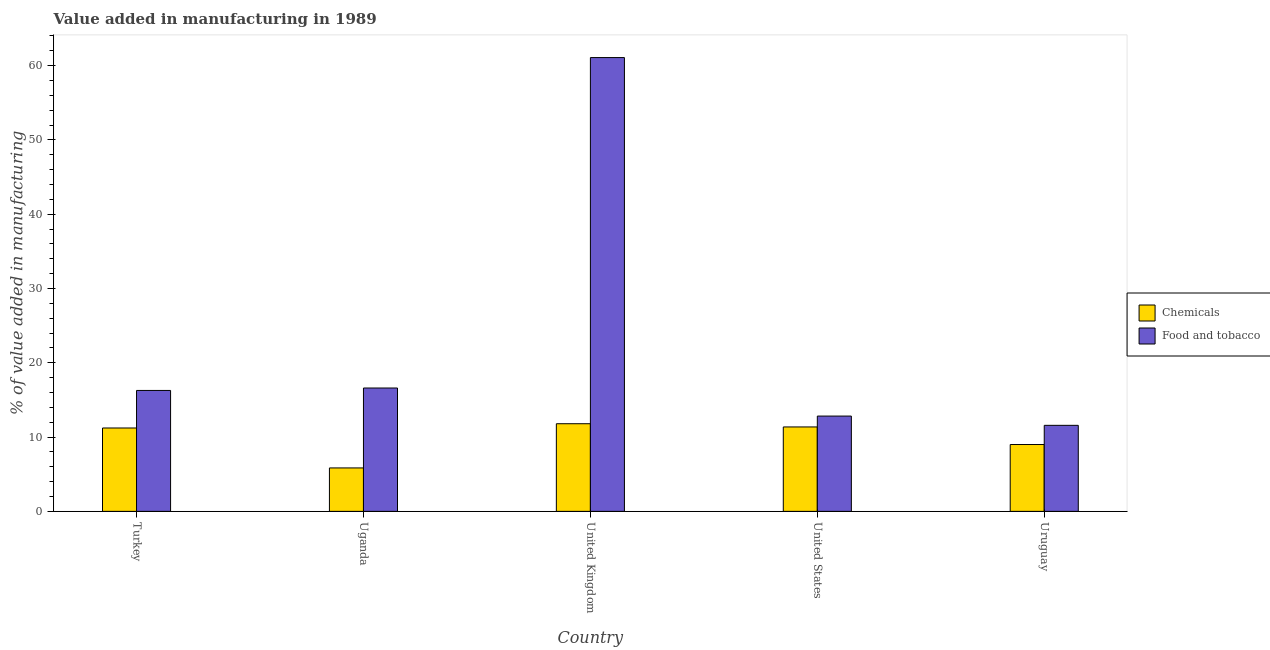How many different coloured bars are there?
Make the answer very short. 2. How many groups of bars are there?
Your response must be concise. 5. Are the number of bars per tick equal to the number of legend labels?
Provide a succinct answer. Yes. How many bars are there on the 3rd tick from the left?
Ensure brevity in your answer.  2. How many bars are there on the 5th tick from the right?
Your answer should be compact. 2. What is the label of the 3rd group of bars from the left?
Your answer should be very brief. United Kingdom. In how many cases, is the number of bars for a given country not equal to the number of legend labels?
Provide a succinct answer. 0. What is the value added by  manufacturing chemicals in Uruguay?
Ensure brevity in your answer.  9. Across all countries, what is the maximum value added by  manufacturing chemicals?
Your answer should be compact. 11.8. Across all countries, what is the minimum value added by manufacturing food and tobacco?
Provide a short and direct response. 11.58. In which country was the value added by  manufacturing chemicals maximum?
Make the answer very short. United Kingdom. In which country was the value added by manufacturing food and tobacco minimum?
Your answer should be compact. Uruguay. What is the total value added by manufacturing food and tobacco in the graph?
Your answer should be compact. 118.36. What is the difference between the value added by  manufacturing chemicals in United Kingdom and that in United States?
Your response must be concise. 0.43. What is the difference between the value added by manufacturing food and tobacco in Turkey and the value added by  manufacturing chemicals in Uruguay?
Keep it short and to the point. 7.28. What is the average value added by  manufacturing chemicals per country?
Provide a succinct answer. 9.84. What is the difference between the value added by  manufacturing chemicals and value added by manufacturing food and tobacco in Uruguay?
Provide a succinct answer. -2.58. In how many countries, is the value added by  manufacturing chemicals greater than 54 %?
Provide a short and direct response. 0. What is the ratio of the value added by  manufacturing chemicals in Uganda to that in United Kingdom?
Offer a terse response. 0.5. Is the value added by manufacturing food and tobacco in United Kingdom less than that in Uruguay?
Offer a terse response. No. Is the difference between the value added by  manufacturing chemicals in Turkey and United Kingdom greater than the difference between the value added by manufacturing food and tobacco in Turkey and United Kingdom?
Make the answer very short. Yes. What is the difference between the highest and the second highest value added by manufacturing food and tobacco?
Offer a very short reply. 44.48. What is the difference between the highest and the lowest value added by manufacturing food and tobacco?
Give a very brief answer. 49.5. In how many countries, is the value added by  manufacturing chemicals greater than the average value added by  manufacturing chemicals taken over all countries?
Your answer should be very brief. 3. What does the 1st bar from the left in Turkey represents?
Offer a very short reply. Chemicals. What does the 1st bar from the right in United States represents?
Give a very brief answer. Food and tobacco. How many bars are there?
Ensure brevity in your answer.  10. How many countries are there in the graph?
Give a very brief answer. 5. Does the graph contain any zero values?
Keep it short and to the point. No. Where does the legend appear in the graph?
Ensure brevity in your answer.  Center right. How are the legend labels stacked?
Provide a short and direct response. Vertical. What is the title of the graph?
Make the answer very short. Value added in manufacturing in 1989. Does "Electricity" appear as one of the legend labels in the graph?
Your answer should be very brief. No. What is the label or title of the X-axis?
Ensure brevity in your answer.  Country. What is the label or title of the Y-axis?
Your answer should be compact. % of value added in manufacturing. What is the % of value added in manufacturing in Chemicals in Turkey?
Your answer should be very brief. 11.22. What is the % of value added in manufacturing in Food and tobacco in Turkey?
Offer a terse response. 16.27. What is the % of value added in manufacturing in Chemicals in Uganda?
Your response must be concise. 5.84. What is the % of value added in manufacturing of Food and tobacco in Uganda?
Your answer should be very brief. 16.6. What is the % of value added in manufacturing in Chemicals in United Kingdom?
Ensure brevity in your answer.  11.8. What is the % of value added in manufacturing of Food and tobacco in United Kingdom?
Your answer should be compact. 61.08. What is the % of value added in manufacturing of Chemicals in United States?
Provide a short and direct response. 11.36. What is the % of value added in manufacturing of Food and tobacco in United States?
Ensure brevity in your answer.  12.83. What is the % of value added in manufacturing of Chemicals in Uruguay?
Offer a terse response. 9. What is the % of value added in manufacturing of Food and tobacco in Uruguay?
Your response must be concise. 11.58. Across all countries, what is the maximum % of value added in manufacturing of Chemicals?
Ensure brevity in your answer.  11.8. Across all countries, what is the maximum % of value added in manufacturing of Food and tobacco?
Your answer should be very brief. 61.08. Across all countries, what is the minimum % of value added in manufacturing in Chemicals?
Give a very brief answer. 5.84. Across all countries, what is the minimum % of value added in manufacturing of Food and tobacco?
Make the answer very short. 11.58. What is the total % of value added in manufacturing in Chemicals in the graph?
Your answer should be compact. 49.22. What is the total % of value added in manufacturing in Food and tobacco in the graph?
Keep it short and to the point. 118.36. What is the difference between the % of value added in manufacturing of Chemicals in Turkey and that in Uganda?
Your answer should be compact. 5.38. What is the difference between the % of value added in manufacturing of Food and tobacco in Turkey and that in Uganda?
Offer a very short reply. -0.33. What is the difference between the % of value added in manufacturing of Chemicals in Turkey and that in United Kingdom?
Your answer should be compact. -0.57. What is the difference between the % of value added in manufacturing of Food and tobacco in Turkey and that in United Kingdom?
Offer a terse response. -44.8. What is the difference between the % of value added in manufacturing in Chemicals in Turkey and that in United States?
Your answer should be compact. -0.14. What is the difference between the % of value added in manufacturing of Food and tobacco in Turkey and that in United States?
Offer a very short reply. 3.45. What is the difference between the % of value added in manufacturing in Chemicals in Turkey and that in Uruguay?
Give a very brief answer. 2.23. What is the difference between the % of value added in manufacturing in Food and tobacco in Turkey and that in Uruguay?
Keep it short and to the point. 4.69. What is the difference between the % of value added in manufacturing in Chemicals in Uganda and that in United Kingdom?
Your answer should be compact. -5.95. What is the difference between the % of value added in manufacturing of Food and tobacco in Uganda and that in United Kingdom?
Provide a short and direct response. -44.48. What is the difference between the % of value added in manufacturing in Chemicals in Uganda and that in United States?
Ensure brevity in your answer.  -5.52. What is the difference between the % of value added in manufacturing in Food and tobacco in Uganda and that in United States?
Provide a short and direct response. 3.78. What is the difference between the % of value added in manufacturing of Chemicals in Uganda and that in Uruguay?
Offer a very short reply. -3.15. What is the difference between the % of value added in manufacturing of Food and tobacco in Uganda and that in Uruguay?
Your answer should be very brief. 5.02. What is the difference between the % of value added in manufacturing in Chemicals in United Kingdom and that in United States?
Your answer should be very brief. 0.43. What is the difference between the % of value added in manufacturing in Food and tobacco in United Kingdom and that in United States?
Your answer should be compact. 48.25. What is the difference between the % of value added in manufacturing of Chemicals in United Kingdom and that in Uruguay?
Provide a succinct answer. 2.8. What is the difference between the % of value added in manufacturing in Food and tobacco in United Kingdom and that in Uruguay?
Offer a terse response. 49.5. What is the difference between the % of value added in manufacturing in Chemicals in United States and that in Uruguay?
Keep it short and to the point. 2.37. What is the difference between the % of value added in manufacturing of Food and tobacco in United States and that in Uruguay?
Your response must be concise. 1.25. What is the difference between the % of value added in manufacturing of Chemicals in Turkey and the % of value added in manufacturing of Food and tobacco in Uganda?
Your answer should be very brief. -5.38. What is the difference between the % of value added in manufacturing in Chemicals in Turkey and the % of value added in manufacturing in Food and tobacco in United Kingdom?
Give a very brief answer. -49.86. What is the difference between the % of value added in manufacturing in Chemicals in Turkey and the % of value added in manufacturing in Food and tobacco in United States?
Make the answer very short. -1.6. What is the difference between the % of value added in manufacturing of Chemicals in Turkey and the % of value added in manufacturing of Food and tobacco in Uruguay?
Ensure brevity in your answer.  -0.36. What is the difference between the % of value added in manufacturing of Chemicals in Uganda and the % of value added in manufacturing of Food and tobacco in United Kingdom?
Ensure brevity in your answer.  -55.23. What is the difference between the % of value added in manufacturing in Chemicals in Uganda and the % of value added in manufacturing in Food and tobacco in United States?
Offer a terse response. -6.98. What is the difference between the % of value added in manufacturing in Chemicals in Uganda and the % of value added in manufacturing in Food and tobacco in Uruguay?
Give a very brief answer. -5.73. What is the difference between the % of value added in manufacturing of Chemicals in United Kingdom and the % of value added in manufacturing of Food and tobacco in United States?
Your answer should be compact. -1.03. What is the difference between the % of value added in manufacturing of Chemicals in United Kingdom and the % of value added in manufacturing of Food and tobacco in Uruguay?
Your answer should be compact. 0.22. What is the difference between the % of value added in manufacturing in Chemicals in United States and the % of value added in manufacturing in Food and tobacco in Uruguay?
Your answer should be compact. -0.22. What is the average % of value added in manufacturing of Chemicals per country?
Your answer should be very brief. 9.84. What is the average % of value added in manufacturing of Food and tobacco per country?
Make the answer very short. 23.67. What is the difference between the % of value added in manufacturing of Chemicals and % of value added in manufacturing of Food and tobacco in Turkey?
Your answer should be very brief. -5.05. What is the difference between the % of value added in manufacturing of Chemicals and % of value added in manufacturing of Food and tobacco in Uganda?
Your answer should be very brief. -10.76. What is the difference between the % of value added in manufacturing of Chemicals and % of value added in manufacturing of Food and tobacco in United Kingdom?
Your answer should be very brief. -49.28. What is the difference between the % of value added in manufacturing of Chemicals and % of value added in manufacturing of Food and tobacco in United States?
Offer a very short reply. -1.46. What is the difference between the % of value added in manufacturing in Chemicals and % of value added in manufacturing in Food and tobacco in Uruguay?
Offer a very short reply. -2.58. What is the ratio of the % of value added in manufacturing of Chemicals in Turkey to that in Uganda?
Make the answer very short. 1.92. What is the ratio of the % of value added in manufacturing of Food and tobacco in Turkey to that in Uganda?
Your answer should be compact. 0.98. What is the ratio of the % of value added in manufacturing in Chemicals in Turkey to that in United Kingdom?
Your response must be concise. 0.95. What is the ratio of the % of value added in manufacturing in Food and tobacco in Turkey to that in United Kingdom?
Provide a succinct answer. 0.27. What is the ratio of the % of value added in manufacturing of Food and tobacco in Turkey to that in United States?
Ensure brevity in your answer.  1.27. What is the ratio of the % of value added in manufacturing in Chemicals in Turkey to that in Uruguay?
Make the answer very short. 1.25. What is the ratio of the % of value added in manufacturing of Food and tobacco in Turkey to that in Uruguay?
Your answer should be very brief. 1.41. What is the ratio of the % of value added in manufacturing of Chemicals in Uganda to that in United Kingdom?
Offer a terse response. 0.5. What is the ratio of the % of value added in manufacturing in Food and tobacco in Uganda to that in United Kingdom?
Give a very brief answer. 0.27. What is the ratio of the % of value added in manufacturing in Chemicals in Uganda to that in United States?
Ensure brevity in your answer.  0.51. What is the ratio of the % of value added in manufacturing of Food and tobacco in Uganda to that in United States?
Your answer should be compact. 1.29. What is the ratio of the % of value added in manufacturing of Chemicals in Uganda to that in Uruguay?
Give a very brief answer. 0.65. What is the ratio of the % of value added in manufacturing of Food and tobacco in Uganda to that in Uruguay?
Offer a terse response. 1.43. What is the ratio of the % of value added in manufacturing of Chemicals in United Kingdom to that in United States?
Provide a short and direct response. 1.04. What is the ratio of the % of value added in manufacturing in Food and tobacco in United Kingdom to that in United States?
Provide a succinct answer. 4.76. What is the ratio of the % of value added in manufacturing in Chemicals in United Kingdom to that in Uruguay?
Ensure brevity in your answer.  1.31. What is the ratio of the % of value added in manufacturing in Food and tobacco in United Kingdom to that in Uruguay?
Provide a short and direct response. 5.27. What is the ratio of the % of value added in manufacturing in Chemicals in United States to that in Uruguay?
Your response must be concise. 1.26. What is the ratio of the % of value added in manufacturing of Food and tobacco in United States to that in Uruguay?
Your answer should be very brief. 1.11. What is the difference between the highest and the second highest % of value added in manufacturing of Chemicals?
Provide a short and direct response. 0.43. What is the difference between the highest and the second highest % of value added in manufacturing in Food and tobacco?
Keep it short and to the point. 44.48. What is the difference between the highest and the lowest % of value added in manufacturing in Chemicals?
Offer a terse response. 5.95. What is the difference between the highest and the lowest % of value added in manufacturing in Food and tobacco?
Provide a succinct answer. 49.5. 